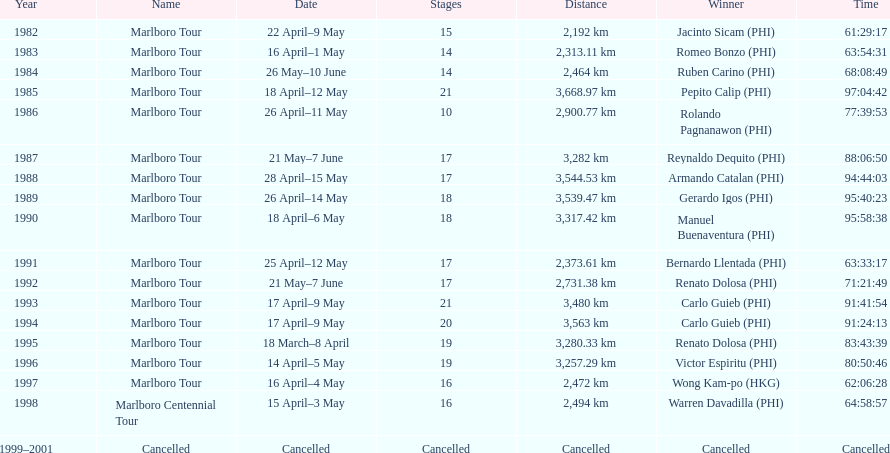Who holds the record for the most victories in marlboro tours? Carlo Guieb. 